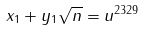Convert formula to latex. <formula><loc_0><loc_0><loc_500><loc_500>x _ { 1 } + y _ { 1 } \sqrt { n } = u ^ { 2 3 2 9 }</formula> 